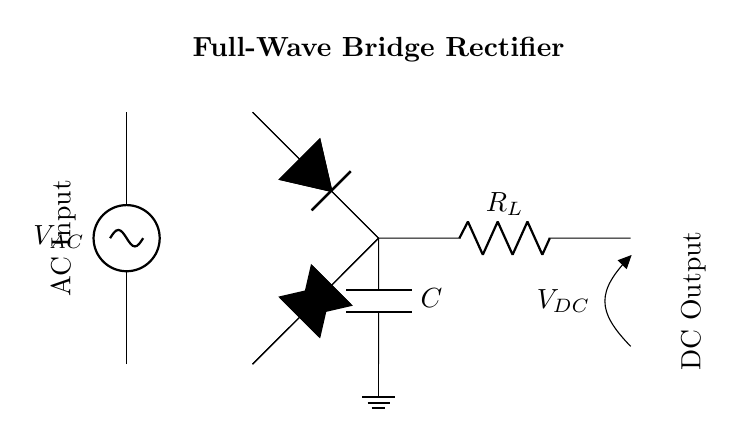What is the type of rectifier shown in the circuit? The circuit is a full-wave bridge rectifier as indicated by the arrangement of four diodes in a bridge configuration.
Answer: full-wave bridge rectifier How many diodes are used in this rectifier? The circuit includes four diodes, which can be visually identified as forming a bridge configuration for rectification.
Answer: four What is the purpose of the load resistor in this circuit? The load resistor is connected in the circuit to provide a pathway for the output current and enable usage of the rectified DC voltage.
Answer: pathway for output current What component smooths out the DC output voltage? The smoothing capacitor is connected parallel to the load resistor and functions to reduce voltage fluctuations in the DC output.
Answer: smoothing capacitor What does the AC input voltage represent? The AC input voltage represents the alternating current voltage supplied to the rectifying circuit, designated as V_AC in the diagram.
Answer: V_AC How is the DC output voltage labeled in the diagram? The DC output voltage is labeled as V_DC, which indicates the voltage after the rectification process and is taken across the load resistor.
Answer: V_DC What would happen if one diode in the bridge is removed? If one diode is removed, the circuit would no longer function as a full-wave rectifier, resulting in only half-wave rectification, leading to a lower voltage output.
Answer: half-wave rectification 